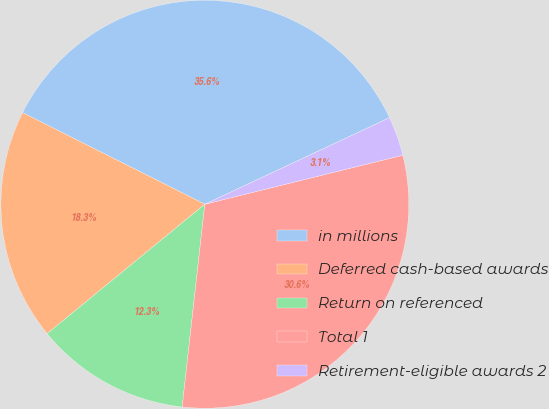<chart> <loc_0><loc_0><loc_500><loc_500><pie_chart><fcel>in millions<fcel>Deferred cash-based awards<fcel>Return on referenced<fcel>Total 1<fcel>Retirement-eligible awards 2<nl><fcel>35.62%<fcel>18.35%<fcel>12.29%<fcel>30.64%<fcel>3.11%<nl></chart> 